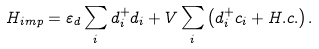<formula> <loc_0><loc_0><loc_500><loc_500>H _ { i m p } = \varepsilon _ { d } \sum _ { i } d _ { i } ^ { + } d _ { i } + V \sum _ { i } \left ( d _ { i } ^ { + } c _ { i } + H . c . \right ) .</formula> 